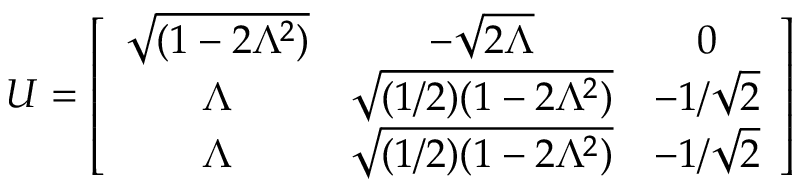Convert formula to latex. <formula><loc_0><loc_0><loc_500><loc_500>U = \left [ \begin{array} { c c c } { { \sqrt { ( 1 - 2 \Lambda ^ { 2 } ) } } } & { { - \sqrt { 2 \Lambda } } } & { 0 } \\ { \Lambda } & { { \sqrt { ( 1 / 2 ) ( 1 - 2 \Lambda ^ { 2 } ) } } } & { { - 1 / \sqrt { 2 } } } \\ { \Lambda } & { { \sqrt { ( 1 / 2 ) ( 1 - 2 \Lambda ^ { 2 } ) } } } & { { - 1 / \sqrt { 2 } } } \end{array} \right ]</formula> 